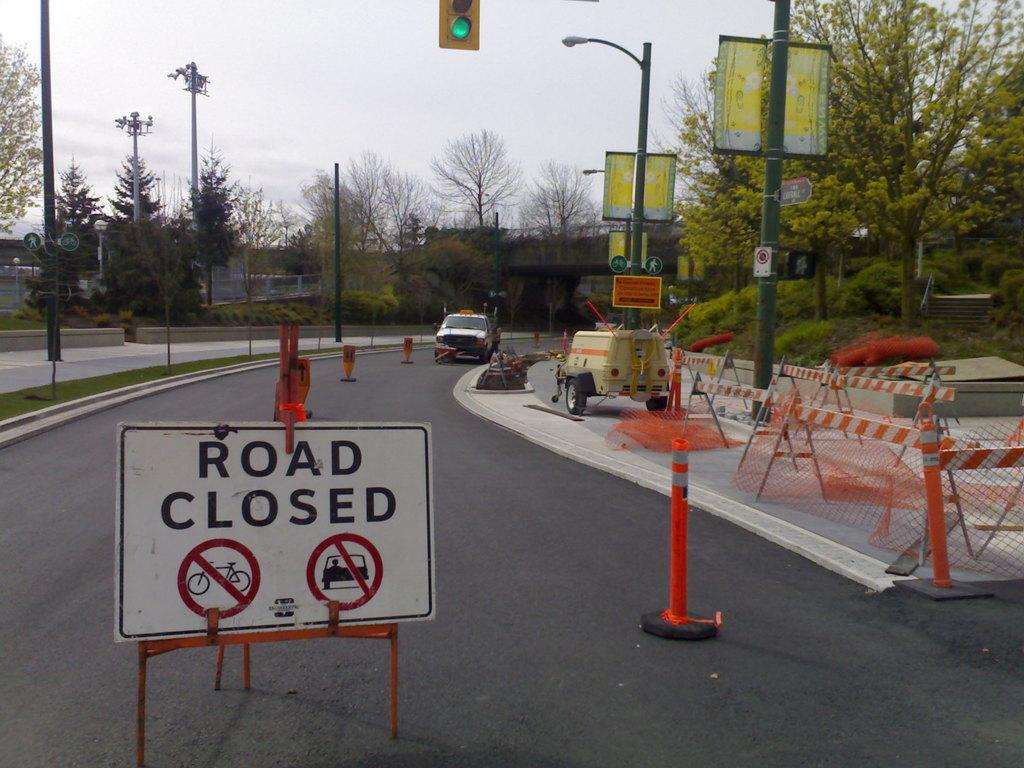<image>
Share a concise interpretation of the image provided. a Road Closed sign in in front of a closed off road 